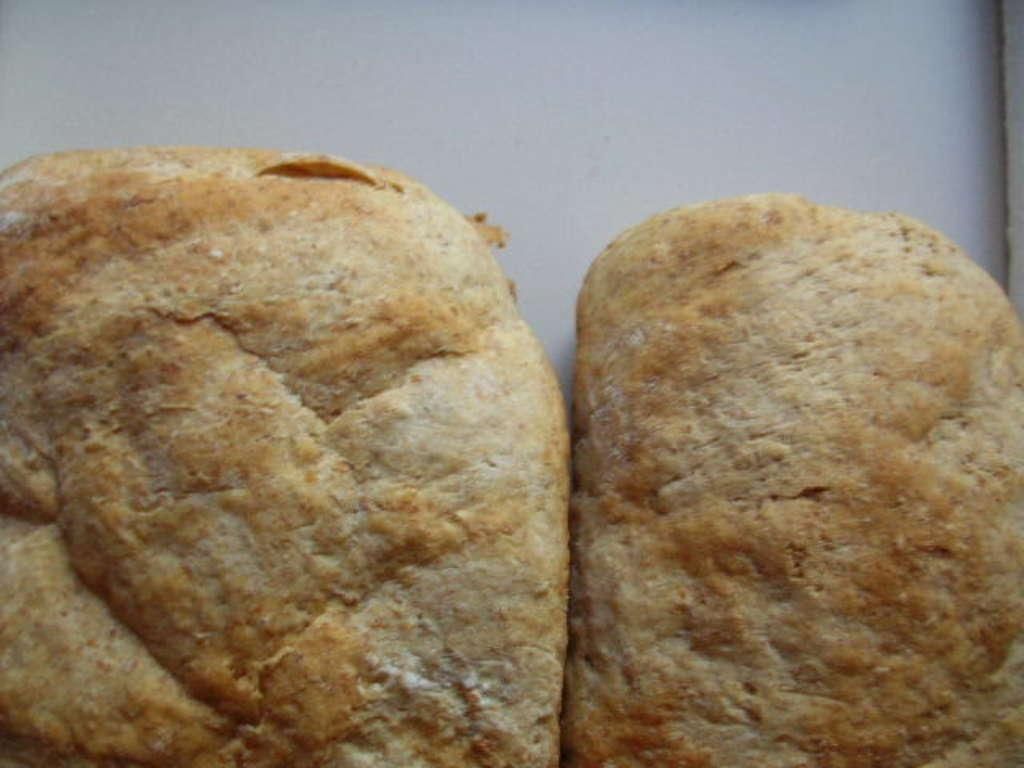What is the main subject of the image? There is an object in the center of the image. What type of songs can be heard coming from the object in the image? There is no indication in the image that the object is producing any sounds or songs, so it's not possible to determine what, if any, songs might be heard. 